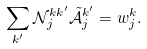Convert formula to latex. <formula><loc_0><loc_0><loc_500><loc_500>\sum _ { k ^ { \prime } } \mathcal { N } ^ { k k ^ { \prime } } _ { j } \tilde { \mathcal { A } } ^ { k ^ { \prime } } _ { j } = w ^ { k } _ { j } .</formula> 